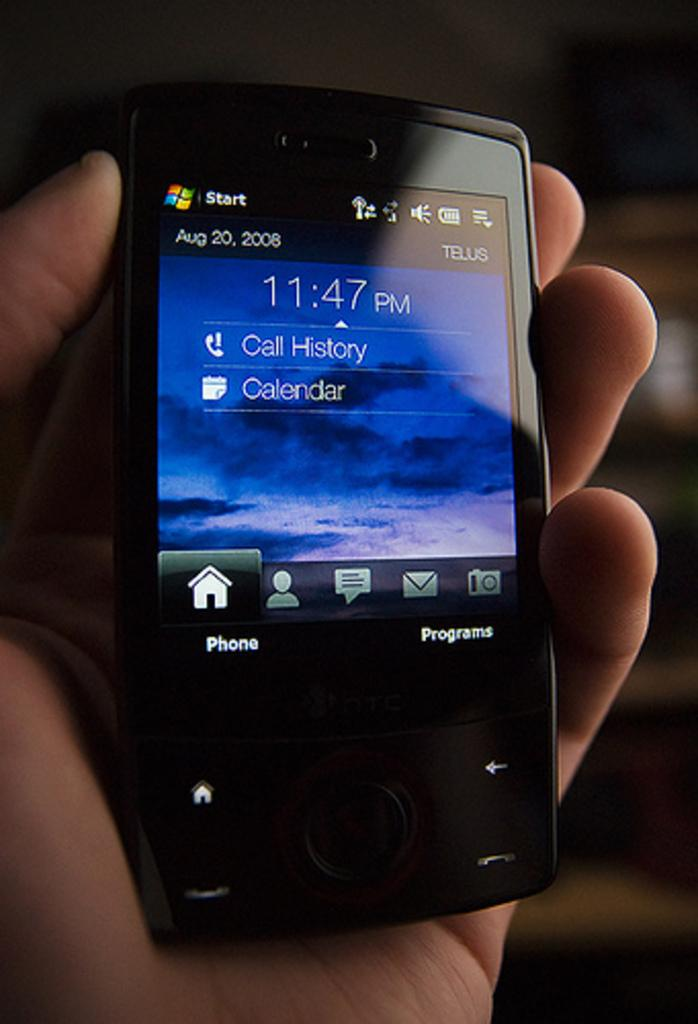What is the main subject of the image? There is a person in the image. What is the person holding in the image? The person is holding a mobile phone. Can you describe the mobile phone in the image? The mobile phone is black in color and has a screen. How many chickens can be seen in the image? There are no chickens present in the image. What type of border is visible in the image? There is no border visible in the image. 